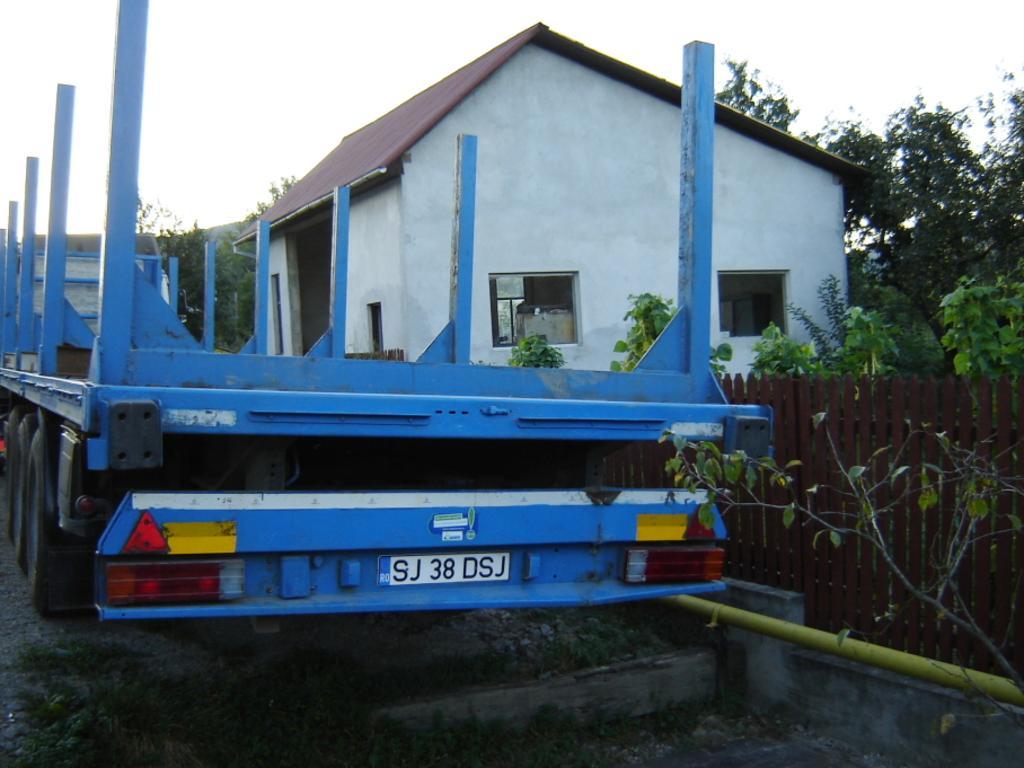How would you summarize this image in a sentence or two? In this image we can see a blue color vehicle on the road. We can also see a house, fence and also many trees. Sky is also visible. 